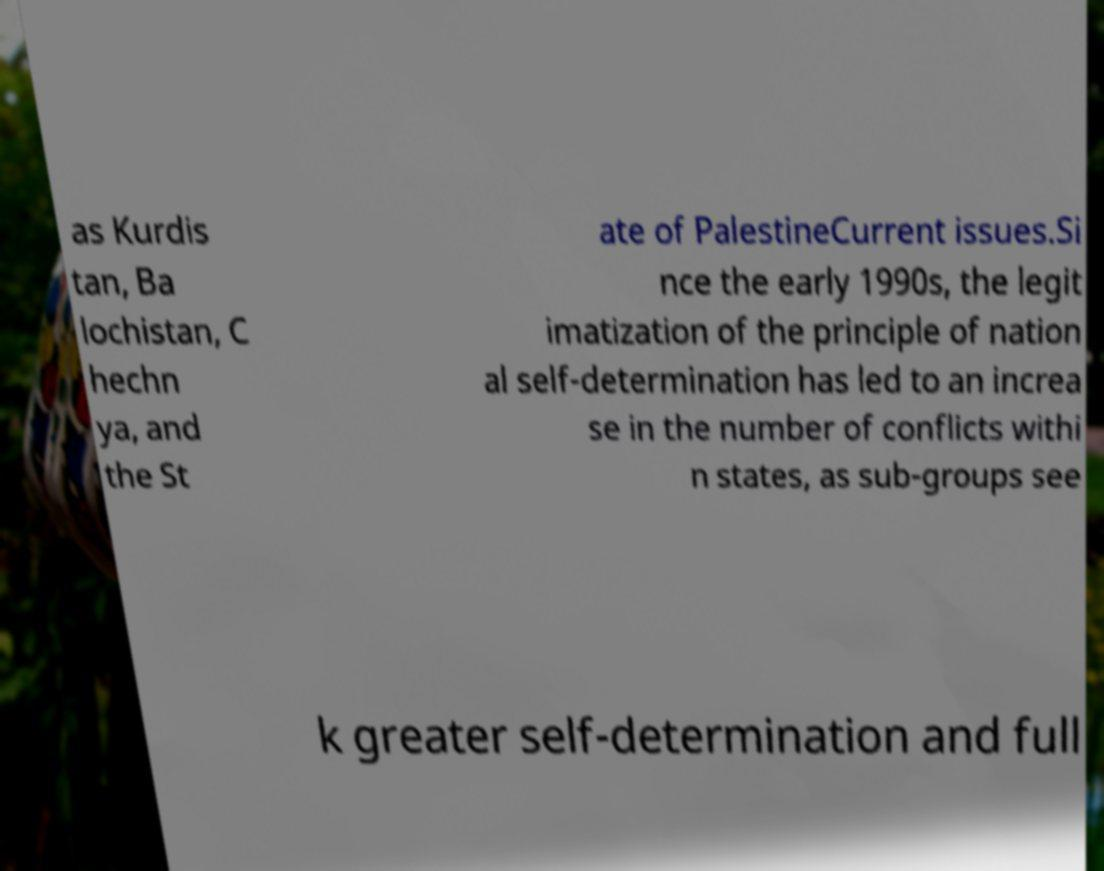For documentation purposes, I need the text within this image transcribed. Could you provide that? as Kurdis tan, Ba lochistan, C hechn ya, and the St ate of PalestineCurrent issues.Si nce the early 1990s, the legit imatization of the principle of nation al self-determination has led to an increa se in the number of conflicts withi n states, as sub-groups see k greater self-determination and full 